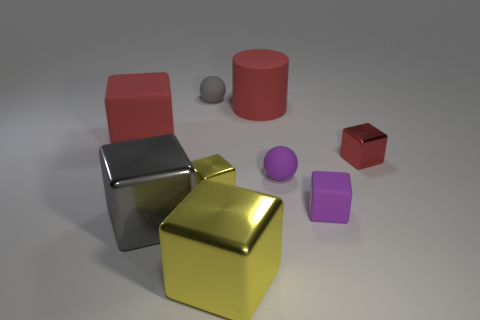What number of small yellow objects are made of the same material as the big gray thing?
Provide a succinct answer. 1. Is there a large red matte cube?
Your answer should be very brief. Yes. How many matte objects have the same color as the large cylinder?
Provide a succinct answer. 1. Is the material of the purple ball the same as the thing on the left side of the large gray shiny thing?
Make the answer very short. Yes. Are there more small rubber things that are right of the large red cylinder than red metallic objects?
Your answer should be compact. Yes. Is there any other thing that has the same size as the purple block?
Your answer should be compact. Yes. Does the cylinder have the same color as the metallic thing on the right side of the large yellow object?
Keep it short and to the point. Yes. Are there the same number of things that are to the left of the big yellow metal cube and red objects that are behind the small yellow cube?
Offer a terse response. No. There is a tiny sphere that is to the left of the red cylinder; what is it made of?
Your answer should be very brief. Rubber. How many objects are either yellow blocks that are in front of the large gray metal cube or big yellow shiny things?
Keep it short and to the point. 1. 